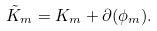Convert formula to latex. <formula><loc_0><loc_0><loc_500><loc_500>\tilde { K } _ { m } = K _ { m } + \partial ( \phi _ { m } ) .</formula> 